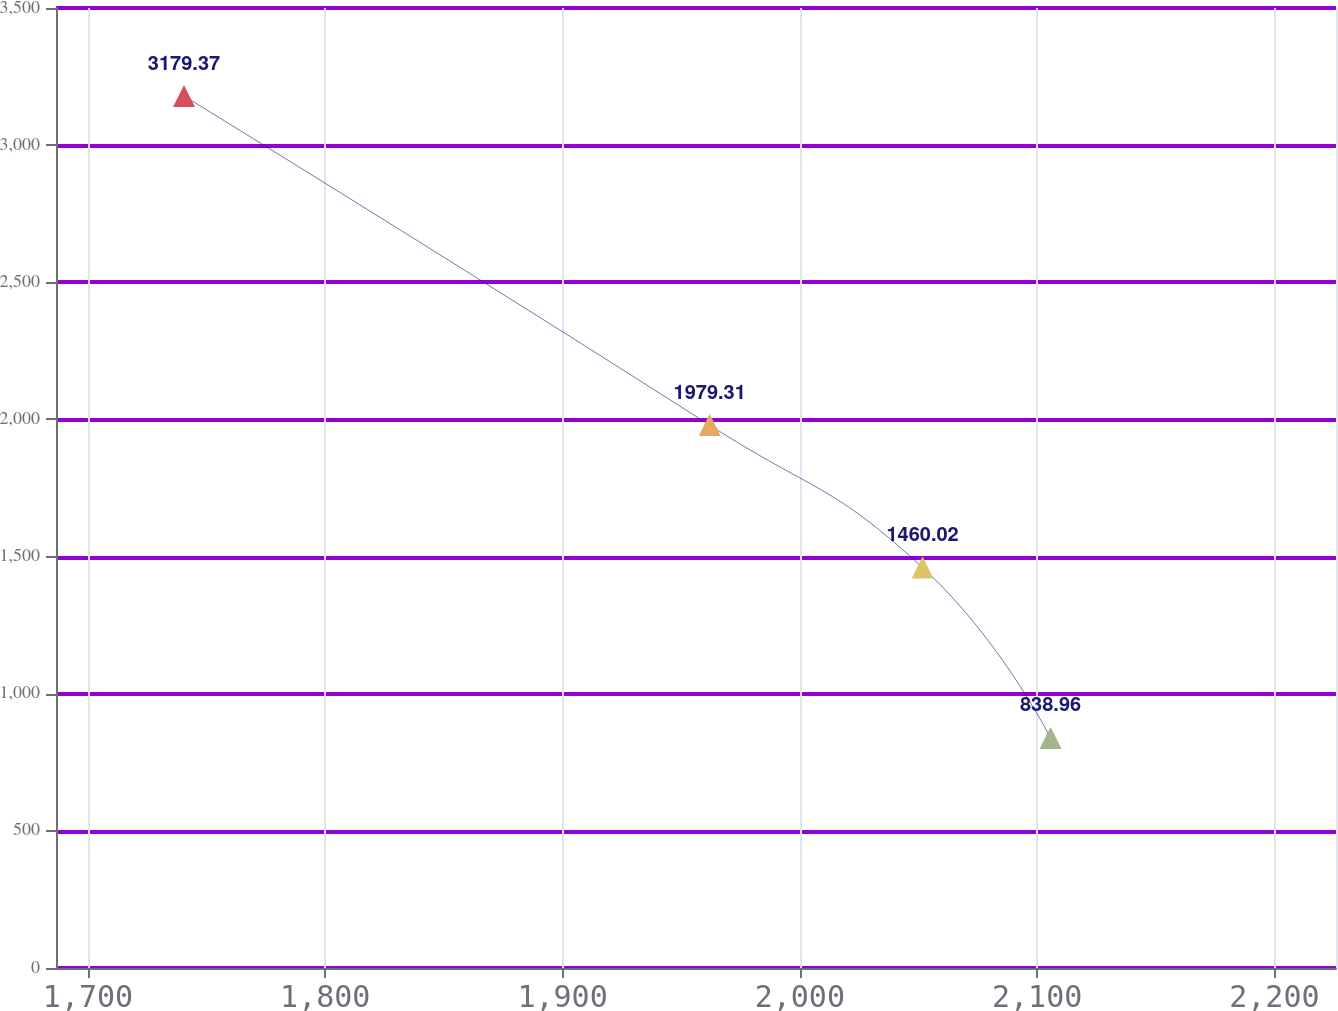Convert chart. <chart><loc_0><loc_0><loc_500><loc_500><line_chart><ecel><fcel>In millions<nl><fcel>1740.47<fcel>3179.37<nl><fcel>1962.01<fcel>1979.31<nl><fcel>2051.73<fcel>1460.02<nl><fcel>2105.67<fcel>838.96<nl><fcel>2279.91<fcel>4.03<nl></chart> 